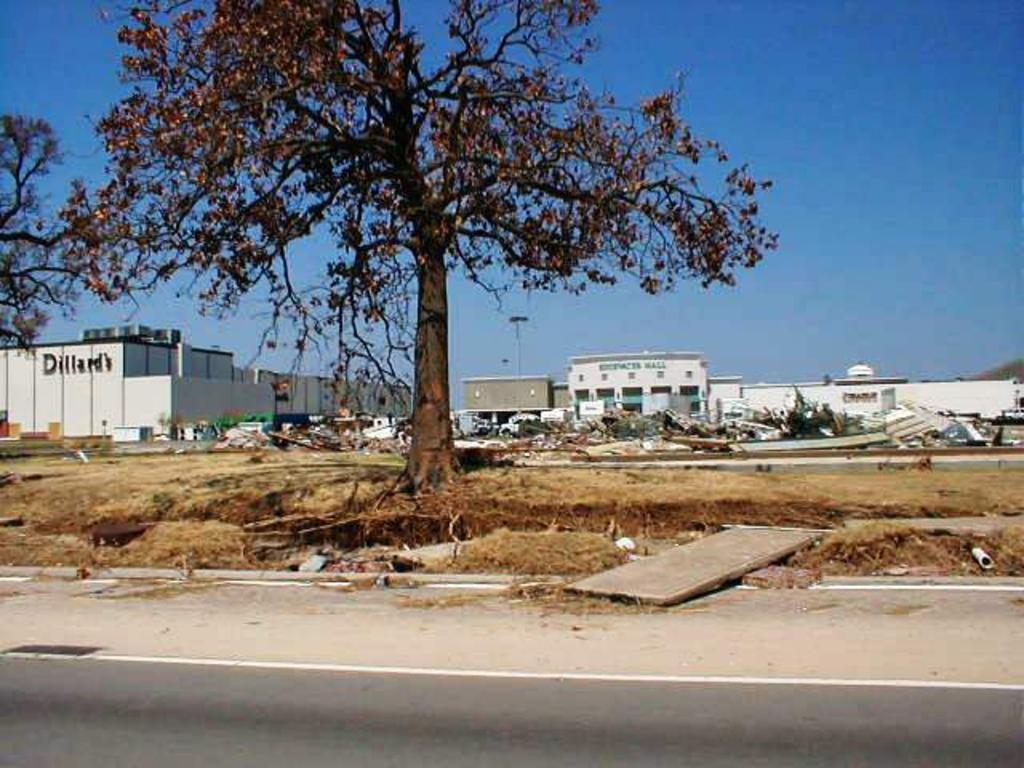How would you summarize this image in a sentence or two? In this image, in the middle there are trees, buildings, many objects, grass, board, road. At the top there is sky. 